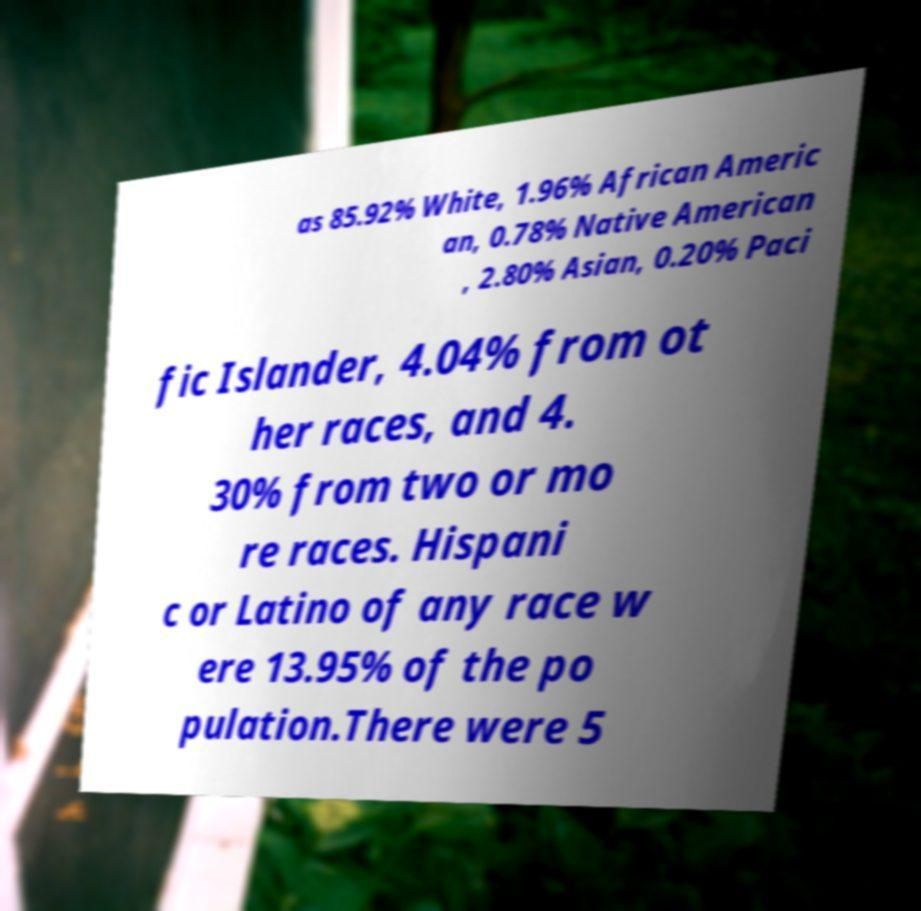For documentation purposes, I need the text within this image transcribed. Could you provide that? as 85.92% White, 1.96% African Americ an, 0.78% Native American , 2.80% Asian, 0.20% Paci fic Islander, 4.04% from ot her races, and 4. 30% from two or mo re races. Hispani c or Latino of any race w ere 13.95% of the po pulation.There were 5 